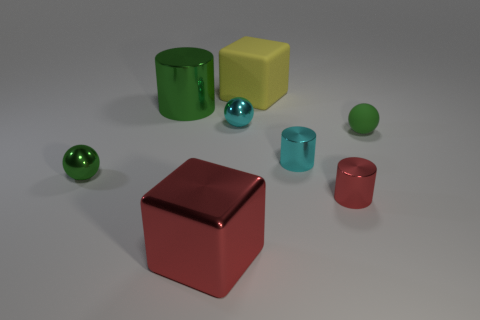What number of other objects are the same color as the large rubber thing?
Your response must be concise. 0. There is a red thing that is right of the large shiny cube; what is its shape?
Ensure brevity in your answer.  Cylinder. How many large cubes are there?
Provide a short and direct response. 2. The big cylinder that is the same material as the tiny red cylinder is what color?
Your answer should be very brief. Green. How many small objects are gray cubes or green cylinders?
Your answer should be compact. 0. What number of tiny red cylinders are in front of the red shiny block?
Give a very brief answer. 0. The other large object that is the same shape as the large matte thing is what color?
Ensure brevity in your answer.  Red. What number of metallic objects are either small red objects or big blue cylinders?
Offer a very short reply. 1. There is a green ball that is right of the red thing that is right of the big rubber block; is there a green metal object in front of it?
Keep it short and to the point. Yes. The big metallic block has what color?
Offer a terse response. Red. 